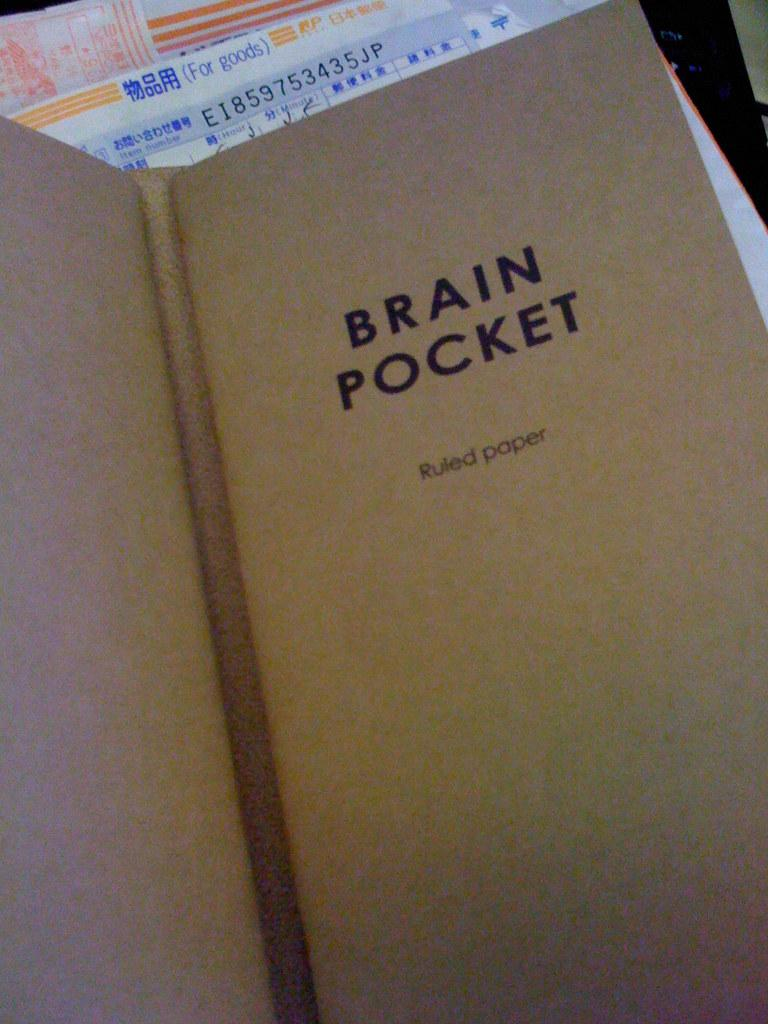<image>
Render a clear and concise summary of the photo. A book of ruled paper by the brand Brain Pocket. 